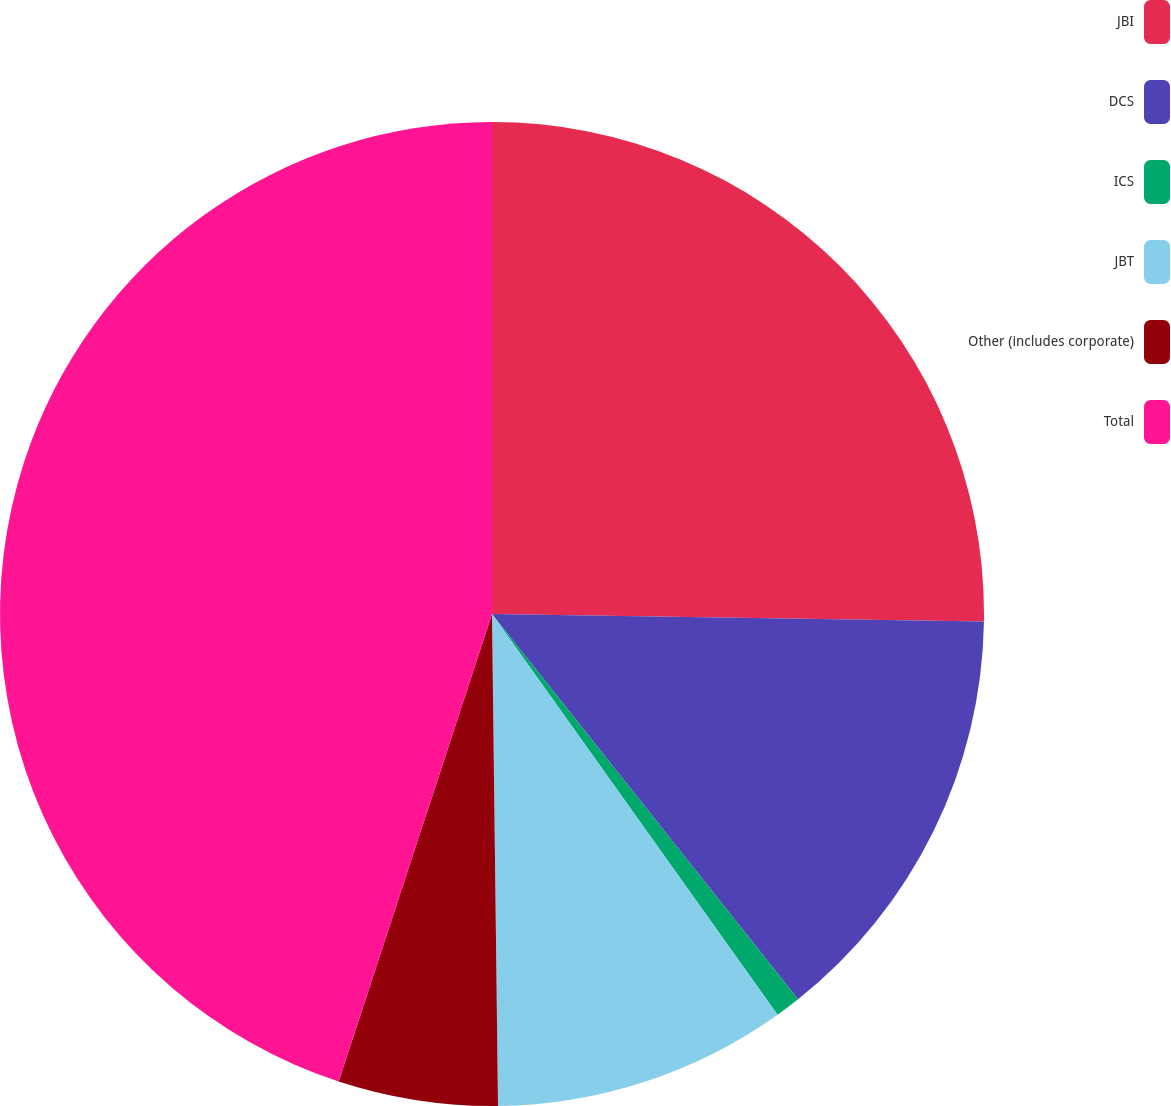Convert chart to OTSL. <chart><loc_0><loc_0><loc_500><loc_500><pie_chart><fcel>JBI<fcel>DCS<fcel>ICS<fcel>JBT<fcel>Other (includes corporate)<fcel>Total<nl><fcel>25.24%<fcel>14.07%<fcel>0.83%<fcel>9.66%<fcel>5.24%<fcel>44.95%<nl></chart> 